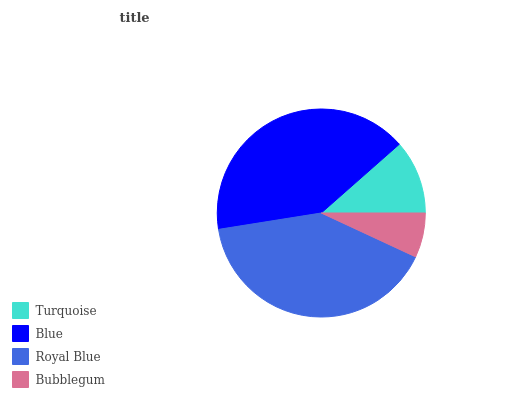Is Bubblegum the minimum?
Answer yes or no. Yes. Is Blue the maximum?
Answer yes or no. Yes. Is Royal Blue the minimum?
Answer yes or no. No. Is Royal Blue the maximum?
Answer yes or no. No. Is Blue greater than Royal Blue?
Answer yes or no. Yes. Is Royal Blue less than Blue?
Answer yes or no. Yes. Is Royal Blue greater than Blue?
Answer yes or no. No. Is Blue less than Royal Blue?
Answer yes or no. No. Is Royal Blue the high median?
Answer yes or no. Yes. Is Turquoise the low median?
Answer yes or no. Yes. Is Blue the high median?
Answer yes or no. No. Is Bubblegum the low median?
Answer yes or no. No. 